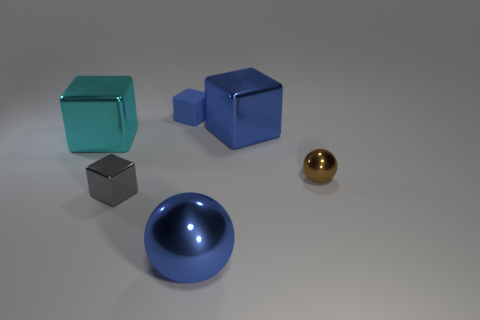Add 1 cyan things. How many objects exist? 7 Subtract all large blue blocks. How many blocks are left? 3 Subtract all blue cubes. How many cubes are left? 2 Subtract all spheres. How many objects are left? 4 Subtract all purple cubes. How many brown balls are left? 1 Subtract all large purple metal cylinders. Subtract all brown things. How many objects are left? 5 Add 3 rubber objects. How many rubber objects are left? 4 Add 4 yellow rubber cylinders. How many yellow rubber cylinders exist? 4 Subtract 0 yellow blocks. How many objects are left? 6 Subtract 1 balls. How many balls are left? 1 